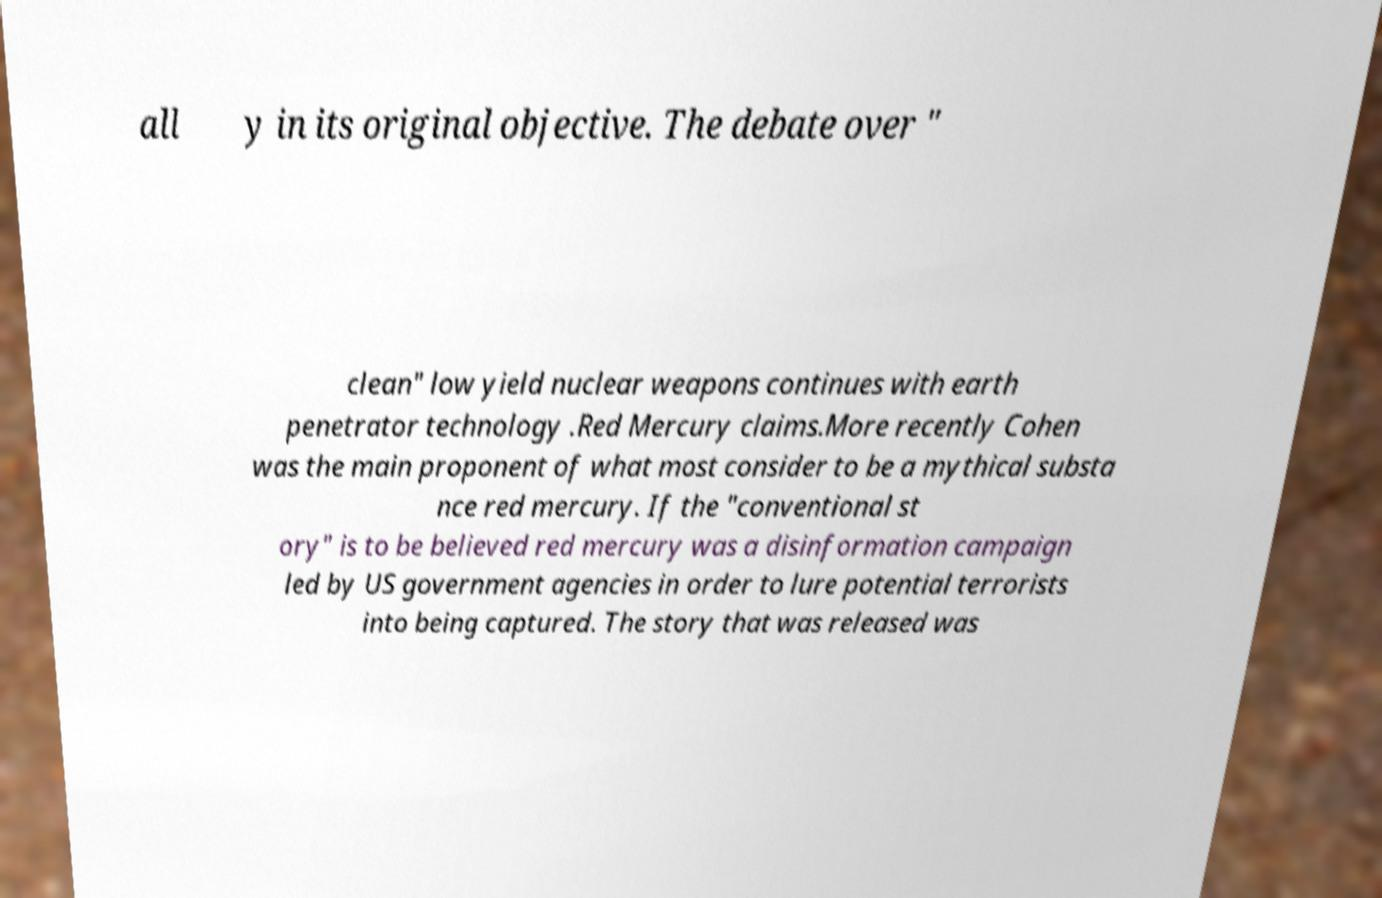Can you read and provide the text displayed in the image?This photo seems to have some interesting text. Can you extract and type it out for me? all y in its original objective. The debate over " clean" low yield nuclear weapons continues with earth penetrator technology .Red Mercury claims.More recently Cohen was the main proponent of what most consider to be a mythical substa nce red mercury. If the "conventional st ory" is to be believed red mercury was a disinformation campaign led by US government agencies in order to lure potential terrorists into being captured. The story that was released was 